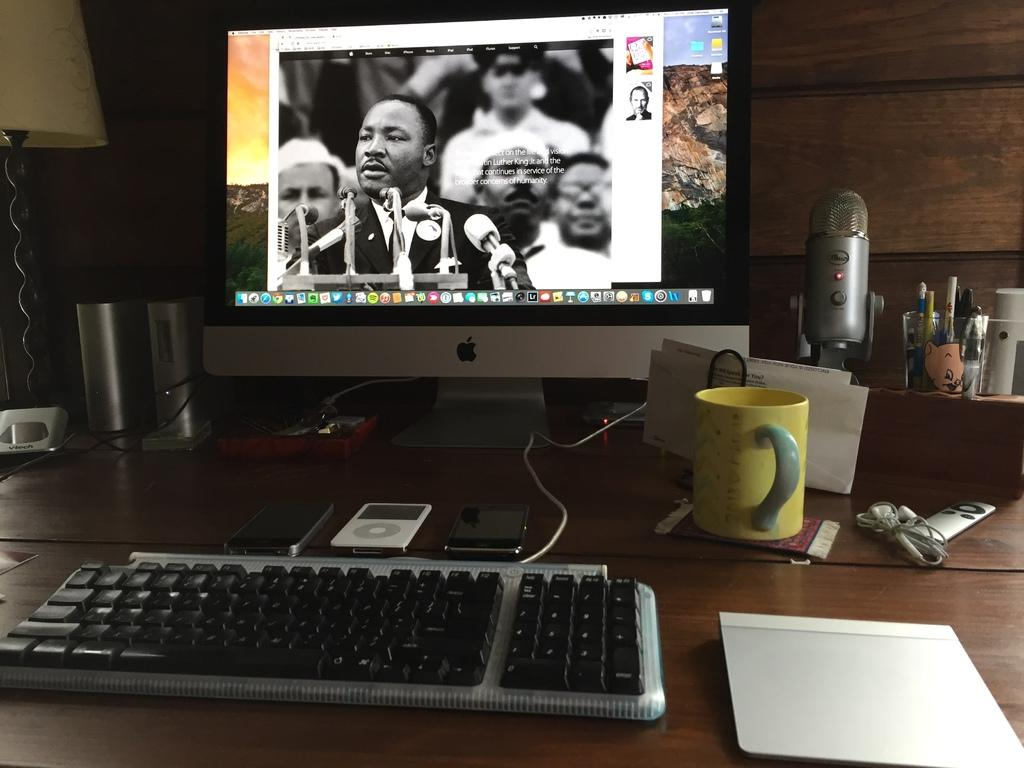What type of objects are present in the image? There are electronic gadgets in the image. Can you describe the main electronic gadget in the image? There is a desktop in the image. Where is the desktop located? The desktop is on a table. What activity is being performed on the desktop? A video clip is being played on the desktop. What word is the desktop using to communicate with the underwear in the image? There is no underwear present in the image, and the desktop is not communicating with any underwear. 